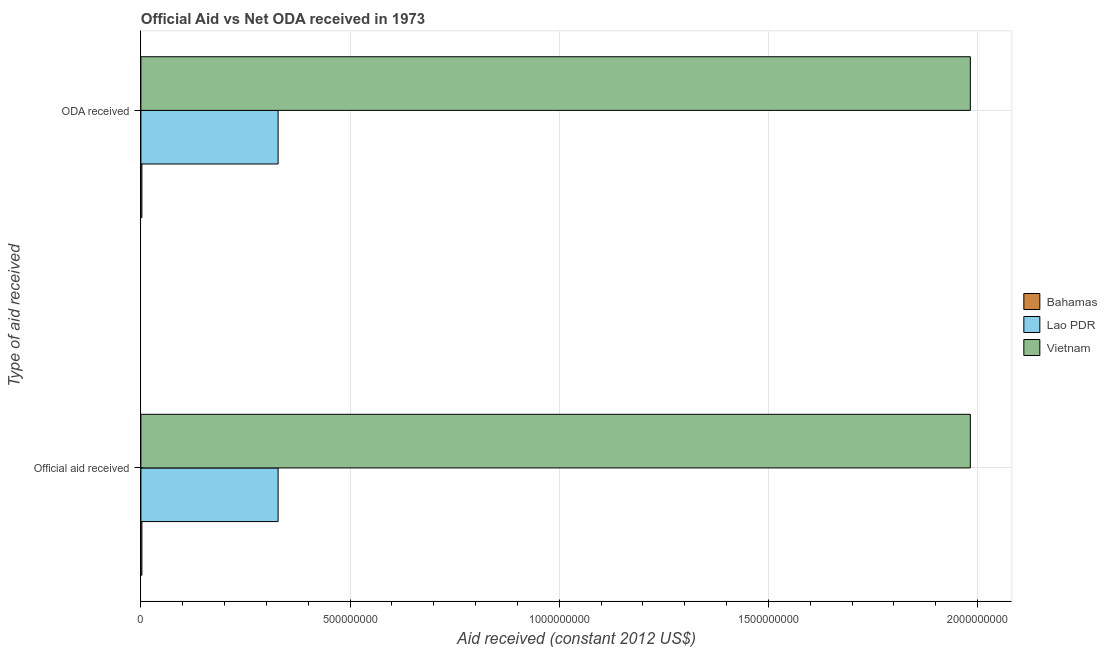How many groups of bars are there?
Provide a succinct answer. 2. Are the number of bars on each tick of the Y-axis equal?
Offer a very short reply. Yes. How many bars are there on the 2nd tick from the top?
Your response must be concise. 3. What is the label of the 1st group of bars from the top?
Keep it short and to the point. ODA received. What is the official aid received in Vietnam?
Provide a short and direct response. 1.98e+09. Across all countries, what is the maximum oda received?
Provide a short and direct response. 1.98e+09. Across all countries, what is the minimum official aid received?
Offer a very short reply. 2.38e+06. In which country was the oda received maximum?
Give a very brief answer. Vietnam. In which country was the official aid received minimum?
Ensure brevity in your answer.  Bahamas. What is the total official aid received in the graph?
Provide a succinct answer. 2.31e+09. What is the difference between the official aid received in Vietnam and that in Bahamas?
Offer a terse response. 1.98e+09. What is the difference between the oda received in Vietnam and the official aid received in Bahamas?
Give a very brief answer. 1.98e+09. What is the average oda received per country?
Provide a succinct answer. 7.71e+08. What is the difference between the official aid received and oda received in Vietnam?
Offer a very short reply. 0. What is the ratio of the official aid received in Lao PDR to that in Bahamas?
Give a very brief answer. 137.81. Is the official aid received in Lao PDR less than that in Bahamas?
Your answer should be very brief. No. In how many countries, is the oda received greater than the average oda received taken over all countries?
Provide a short and direct response. 1. What does the 3rd bar from the top in ODA received represents?
Make the answer very short. Bahamas. What does the 1st bar from the bottom in Official aid received represents?
Offer a terse response. Bahamas. How many bars are there?
Provide a succinct answer. 6. How many countries are there in the graph?
Make the answer very short. 3. What is the difference between two consecutive major ticks on the X-axis?
Provide a short and direct response. 5.00e+08. Are the values on the major ticks of X-axis written in scientific E-notation?
Give a very brief answer. No. How are the legend labels stacked?
Keep it short and to the point. Vertical. What is the title of the graph?
Make the answer very short. Official Aid vs Net ODA received in 1973 . Does "Qatar" appear as one of the legend labels in the graph?
Offer a terse response. No. What is the label or title of the X-axis?
Your answer should be very brief. Aid received (constant 2012 US$). What is the label or title of the Y-axis?
Provide a short and direct response. Type of aid received. What is the Aid received (constant 2012 US$) of Bahamas in Official aid received?
Provide a short and direct response. 2.38e+06. What is the Aid received (constant 2012 US$) of Lao PDR in Official aid received?
Provide a short and direct response. 3.28e+08. What is the Aid received (constant 2012 US$) of Vietnam in Official aid received?
Give a very brief answer. 1.98e+09. What is the Aid received (constant 2012 US$) of Bahamas in ODA received?
Offer a very short reply. 2.38e+06. What is the Aid received (constant 2012 US$) in Lao PDR in ODA received?
Ensure brevity in your answer.  3.28e+08. What is the Aid received (constant 2012 US$) in Vietnam in ODA received?
Your response must be concise. 1.98e+09. Across all Type of aid received, what is the maximum Aid received (constant 2012 US$) in Bahamas?
Your answer should be compact. 2.38e+06. Across all Type of aid received, what is the maximum Aid received (constant 2012 US$) of Lao PDR?
Provide a succinct answer. 3.28e+08. Across all Type of aid received, what is the maximum Aid received (constant 2012 US$) of Vietnam?
Offer a terse response. 1.98e+09. Across all Type of aid received, what is the minimum Aid received (constant 2012 US$) of Bahamas?
Your response must be concise. 2.38e+06. Across all Type of aid received, what is the minimum Aid received (constant 2012 US$) in Lao PDR?
Your response must be concise. 3.28e+08. Across all Type of aid received, what is the minimum Aid received (constant 2012 US$) of Vietnam?
Give a very brief answer. 1.98e+09. What is the total Aid received (constant 2012 US$) in Bahamas in the graph?
Ensure brevity in your answer.  4.76e+06. What is the total Aid received (constant 2012 US$) of Lao PDR in the graph?
Keep it short and to the point. 6.56e+08. What is the total Aid received (constant 2012 US$) of Vietnam in the graph?
Keep it short and to the point. 3.97e+09. What is the difference between the Aid received (constant 2012 US$) in Lao PDR in Official aid received and that in ODA received?
Your answer should be compact. 0. What is the difference between the Aid received (constant 2012 US$) in Vietnam in Official aid received and that in ODA received?
Ensure brevity in your answer.  0. What is the difference between the Aid received (constant 2012 US$) of Bahamas in Official aid received and the Aid received (constant 2012 US$) of Lao PDR in ODA received?
Ensure brevity in your answer.  -3.26e+08. What is the difference between the Aid received (constant 2012 US$) of Bahamas in Official aid received and the Aid received (constant 2012 US$) of Vietnam in ODA received?
Your response must be concise. -1.98e+09. What is the difference between the Aid received (constant 2012 US$) in Lao PDR in Official aid received and the Aid received (constant 2012 US$) in Vietnam in ODA received?
Make the answer very short. -1.65e+09. What is the average Aid received (constant 2012 US$) of Bahamas per Type of aid received?
Give a very brief answer. 2.38e+06. What is the average Aid received (constant 2012 US$) of Lao PDR per Type of aid received?
Offer a very short reply. 3.28e+08. What is the average Aid received (constant 2012 US$) in Vietnam per Type of aid received?
Your response must be concise. 1.98e+09. What is the difference between the Aid received (constant 2012 US$) in Bahamas and Aid received (constant 2012 US$) in Lao PDR in Official aid received?
Offer a very short reply. -3.26e+08. What is the difference between the Aid received (constant 2012 US$) in Bahamas and Aid received (constant 2012 US$) in Vietnam in Official aid received?
Offer a very short reply. -1.98e+09. What is the difference between the Aid received (constant 2012 US$) in Lao PDR and Aid received (constant 2012 US$) in Vietnam in Official aid received?
Your response must be concise. -1.65e+09. What is the difference between the Aid received (constant 2012 US$) in Bahamas and Aid received (constant 2012 US$) in Lao PDR in ODA received?
Ensure brevity in your answer.  -3.26e+08. What is the difference between the Aid received (constant 2012 US$) of Bahamas and Aid received (constant 2012 US$) of Vietnam in ODA received?
Offer a very short reply. -1.98e+09. What is the difference between the Aid received (constant 2012 US$) in Lao PDR and Aid received (constant 2012 US$) in Vietnam in ODA received?
Make the answer very short. -1.65e+09. What is the ratio of the Aid received (constant 2012 US$) of Bahamas in Official aid received to that in ODA received?
Provide a short and direct response. 1. What is the ratio of the Aid received (constant 2012 US$) of Lao PDR in Official aid received to that in ODA received?
Make the answer very short. 1. What is the ratio of the Aid received (constant 2012 US$) in Vietnam in Official aid received to that in ODA received?
Your answer should be compact. 1. 